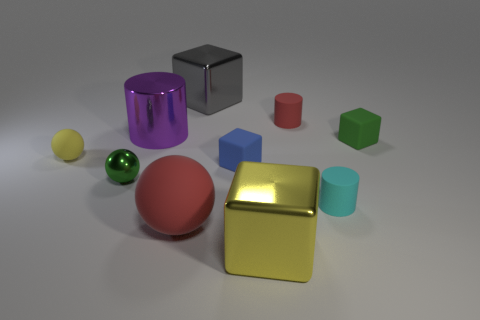What number of other things are there of the same shape as the big purple metallic thing?
Provide a succinct answer. 2. What shape is the object in front of the red matte object that is in front of the tiny green object on the left side of the yellow shiny cube?
Your response must be concise. Cube. What number of spheres are either small things or yellow rubber things?
Provide a succinct answer. 2. There is a red matte thing that is behind the big purple metal thing; are there any large purple things that are in front of it?
Your answer should be compact. Yes. Is there anything else that is made of the same material as the tiny cyan cylinder?
Make the answer very short. Yes. Do the gray object and the green thing that is right of the large yellow object have the same shape?
Offer a very short reply. Yes. What number of other objects are the same size as the blue cube?
Keep it short and to the point. 5. How many red things are tiny objects or spheres?
Your answer should be compact. 2. How many rubber objects are to the right of the green sphere and left of the gray block?
Give a very brief answer. 1. There is a red thing left of the large yellow metal cube that is on the right side of the rubber thing to the left of the red ball; what is it made of?
Offer a terse response. Rubber. 